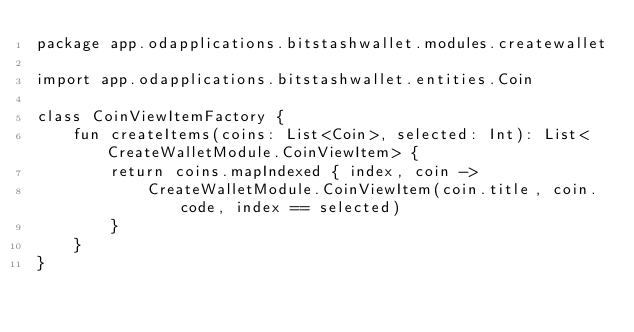Convert code to text. <code><loc_0><loc_0><loc_500><loc_500><_Kotlin_>package app.odapplications.bitstashwallet.modules.createwallet

import app.odapplications.bitstashwallet.entities.Coin

class CoinViewItemFactory {
    fun createItems(coins: List<Coin>, selected: Int): List<CreateWalletModule.CoinViewItem> {
        return coins.mapIndexed { index, coin ->
            CreateWalletModule.CoinViewItem(coin.title, coin.code, index == selected)
        }
    }
}
</code> 